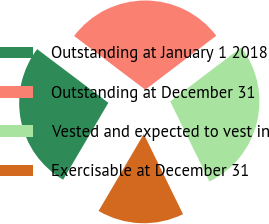Convert chart to OTSL. <chart><loc_0><loc_0><loc_500><loc_500><pie_chart><fcel>Outstanding at January 1 2018<fcel>Outstanding at December 31<fcel>Vested and expected to vest in<fcel>Exercisable at December 31<nl><fcel>26.83%<fcel>29.37%<fcel>28.1%<fcel>15.7%<nl></chart> 